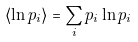Convert formula to latex. <formula><loc_0><loc_0><loc_500><loc_500>\langle \ln p _ { i } \rangle = \sum _ { i } p _ { i } \ln p _ { i }</formula> 